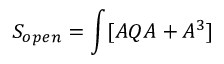<formula> <loc_0><loc_0><loc_500><loc_500>S _ { o p e n } = \int [ A Q A + A ^ { 3 } ]</formula> 